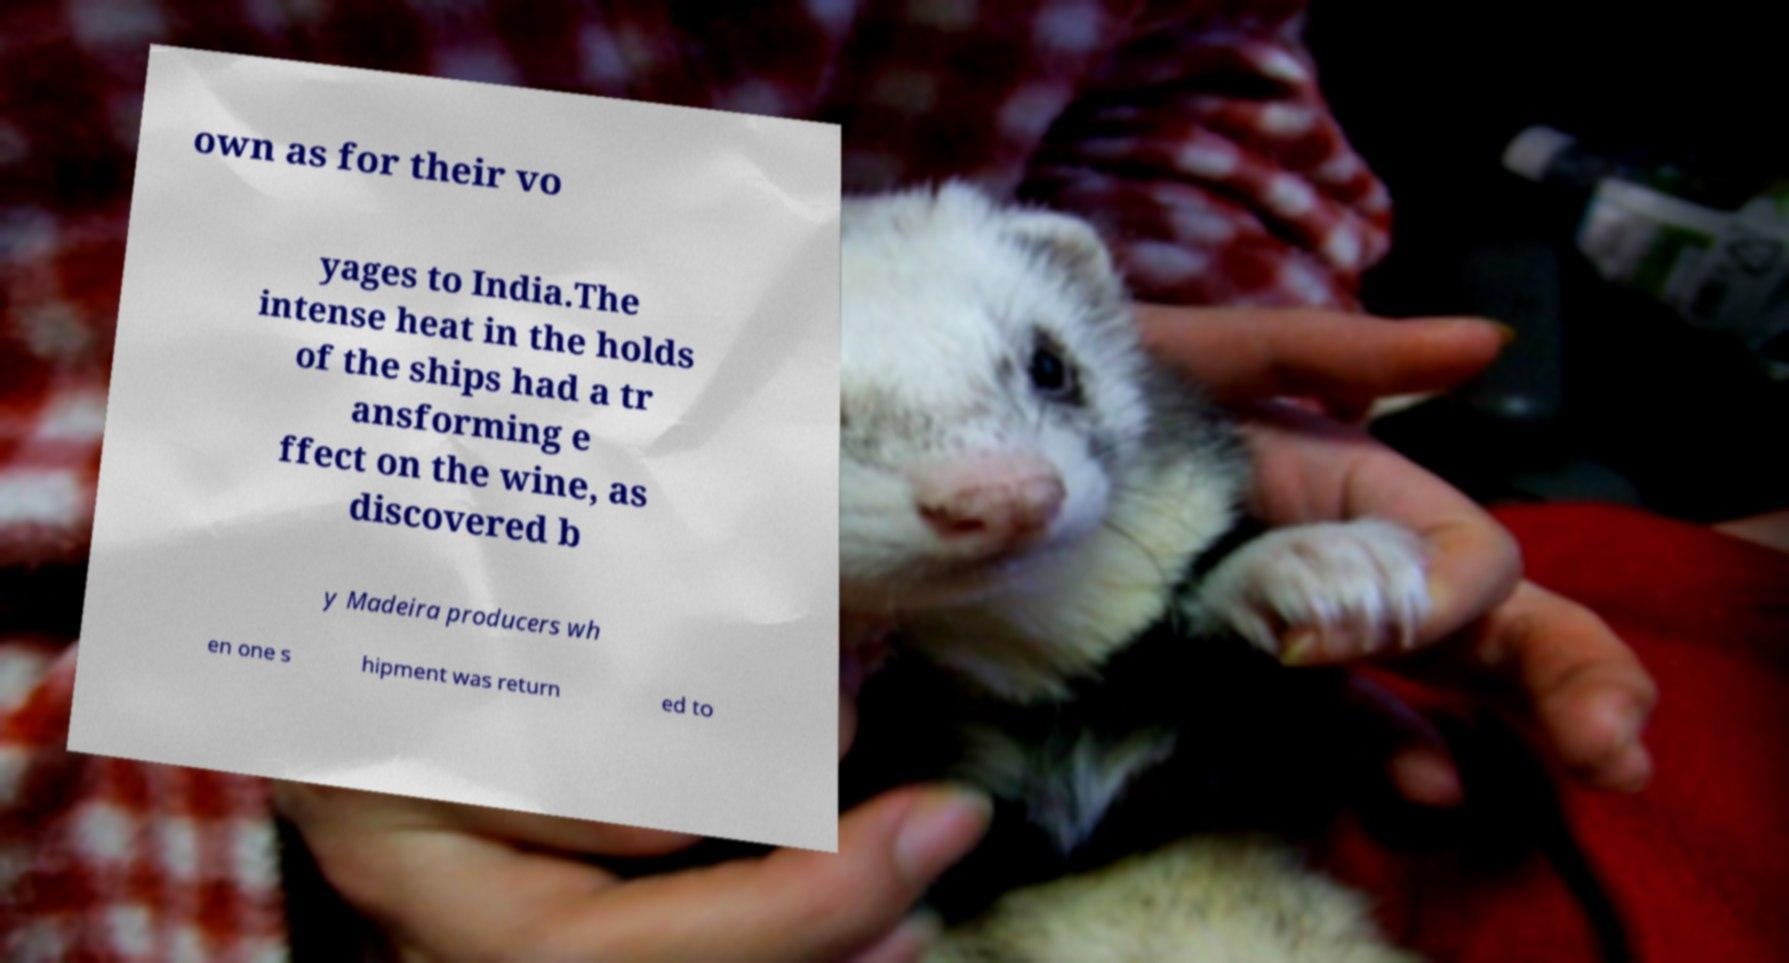Can you accurately transcribe the text from the provided image for me? own as for their vo yages to India.The intense heat in the holds of the ships had a tr ansforming e ffect on the wine, as discovered b y Madeira producers wh en one s hipment was return ed to 